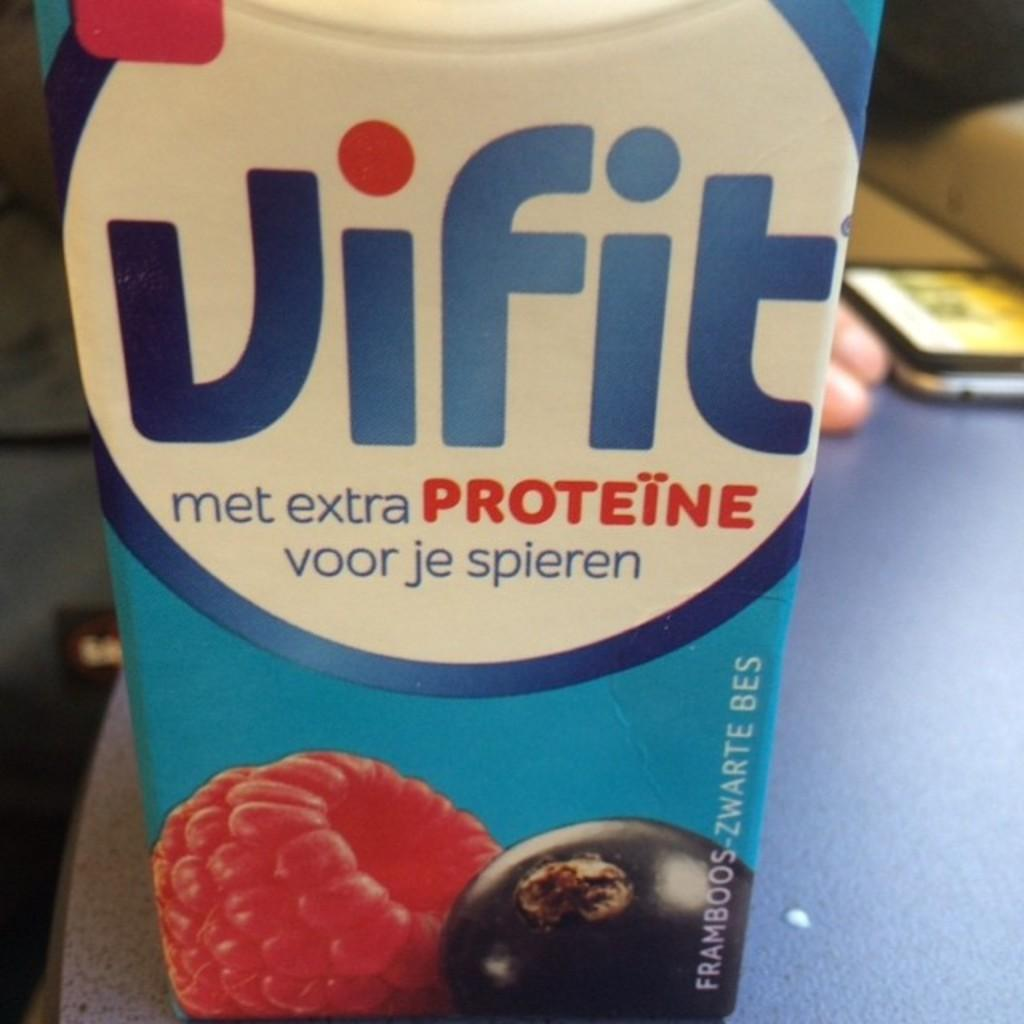What type of beverage is in the container that is visible in the image? There is a tetra pack fruit juice in the image. Where is the tetra pack fruit juice located? The tetra pack fruit juice is on a table. Can you describe the presence of a person in the image? There appears to be a person behind the tetra pack fruit juice. What statement does the person's brother make about the fruit juice in the image? There is no information about the person's brother or any statements they might make in the image. Where can you buy the fruit juice in the image? The image does not provide information about where to buy the fruit juice; it only shows the fruit juice on a table. 